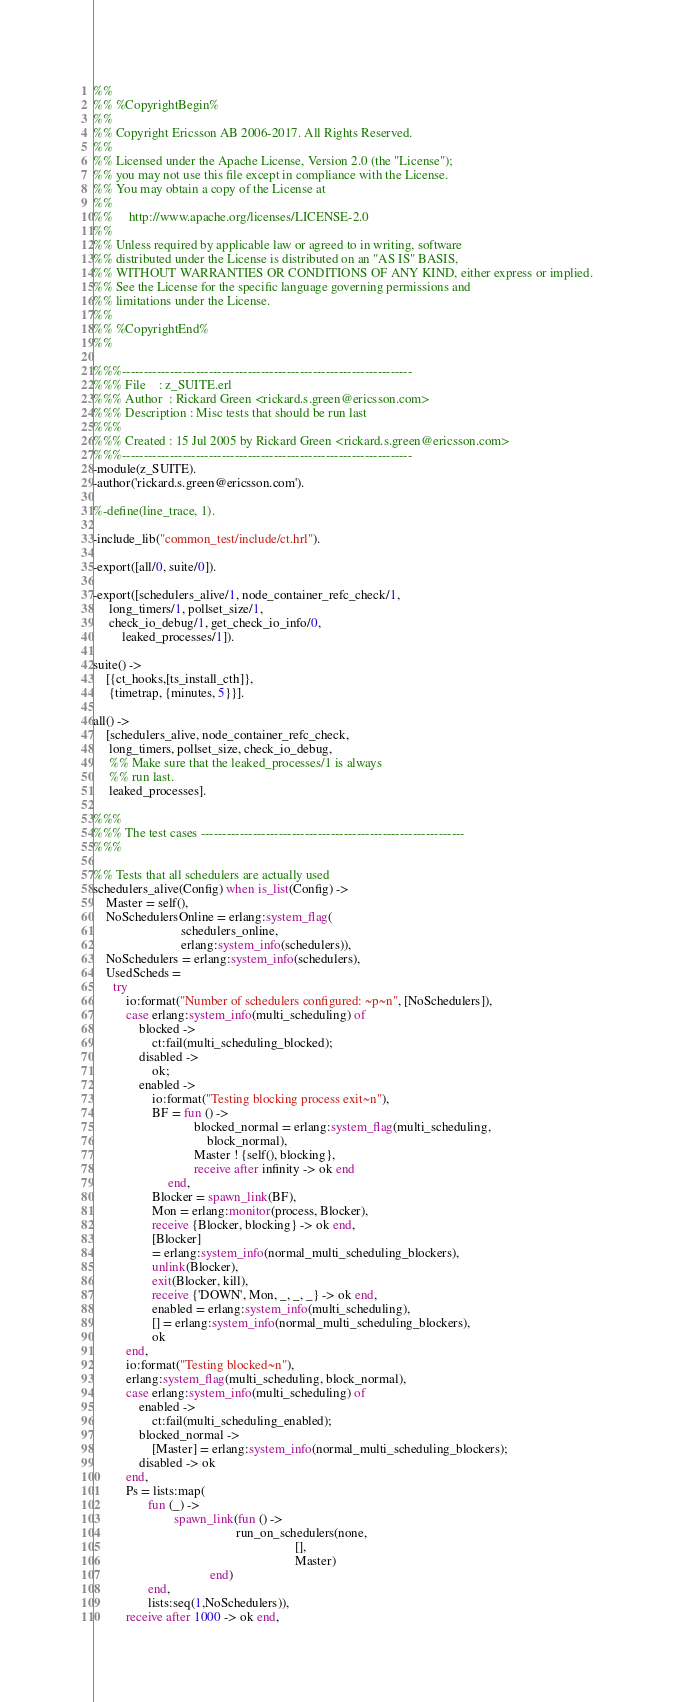<code> <loc_0><loc_0><loc_500><loc_500><_Erlang_>%%
%% %CopyrightBegin%
%% 
%% Copyright Ericsson AB 2006-2017. All Rights Reserved.
%% 
%% Licensed under the Apache License, Version 2.0 (the "License");
%% you may not use this file except in compliance with the License.
%% You may obtain a copy of the License at
%%
%%     http://www.apache.org/licenses/LICENSE-2.0
%%
%% Unless required by applicable law or agreed to in writing, software
%% distributed under the License is distributed on an "AS IS" BASIS,
%% WITHOUT WARRANTIES OR CONDITIONS OF ANY KIND, either express or implied.
%% See the License for the specific language governing permissions and
%% limitations under the License.
%% 
%% %CopyrightEnd%
%%

%%%-------------------------------------------------------------------
%%% File    : z_SUITE.erl
%%% Author  : Rickard Green <rickard.s.green@ericsson.com>
%%% Description : Misc tests that should be run last
%%%
%%% Created : 15 Jul 2005 by Rickard Green <rickard.s.green@ericsson.com>
%%%-------------------------------------------------------------------
-module(z_SUITE).
-author('rickard.s.green@ericsson.com').

%-define(line_trace, 1).

-include_lib("common_test/include/ct.hrl").

-export([all/0, suite/0]).

-export([schedulers_alive/1, node_container_refc_check/1,
	 long_timers/1, pollset_size/1,
	 check_io_debug/1, get_check_io_info/0,
         leaked_processes/1]).

suite() ->
    [{ct_hooks,[ts_install_cth]},
     {timetrap, {minutes, 5}}].

all() -> 
    [schedulers_alive, node_container_refc_check,
     long_timers, pollset_size, check_io_debug,
     %% Make sure that the leaked_processes/1 is always
     %% run last.
     leaked_processes].

%%%
%%% The test cases -------------------------------------------------------------
%%%

%% Tests that all schedulers are actually used
schedulers_alive(Config) when is_list(Config) ->
    Master = self(),
    NoSchedulersOnline = erlang:system_flag(
                           schedulers_online,
                           erlang:system_info(schedulers)),
    NoSchedulers = erlang:system_info(schedulers),
    UsedScheds =
      try
          io:format("Number of schedulers configured: ~p~n", [NoSchedulers]),
          case erlang:system_info(multi_scheduling) of
              blocked ->
                  ct:fail(multi_scheduling_blocked);
              disabled ->
                  ok;
              enabled ->
                  io:format("Testing blocking process exit~n"),
                  BF = fun () ->
                               blocked_normal = erlang:system_flag(multi_scheduling,
								   block_normal),
                               Master ! {self(), blocking},
                               receive after infinity -> ok end
                       end,
                  Blocker = spawn_link(BF),
                  Mon = erlang:monitor(process, Blocker),
                  receive {Blocker, blocking} -> ok end,
                  [Blocker]
                  = erlang:system_info(normal_multi_scheduling_blockers),
                  unlink(Blocker),
                  exit(Blocker, kill),
                  receive {'DOWN', Mon, _, _, _} -> ok end,
                  enabled = erlang:system_info(multi_scheduling),
                  [] = erlang:system_info(normal_multi_scheduling_blockers),
                  ok
          end,
          io:format("Testing blocked~n"),
          erlang:system_flag(multi_scheduling, block_normal),
          case erlang:system_info(multi_scheduling) of
              enabled ->
                  ct:fail(multi_scheduling_enabled);
              blocked_normal ->
                  [Master] = erlang:system_info(normal_multi_scheduling_blockers);
              disabled -> ok
          end,
          Ps = lists:map(
                 fun (_) ->
                         spawn_link(fun () ->
                                            run_on_schedulers(none,
                                                              [],
                                                              Master)
                                    end)
                 end,
                 lists:seq(1,NoSchedulers)),
          receive after 1000 -> ok end,</code> 